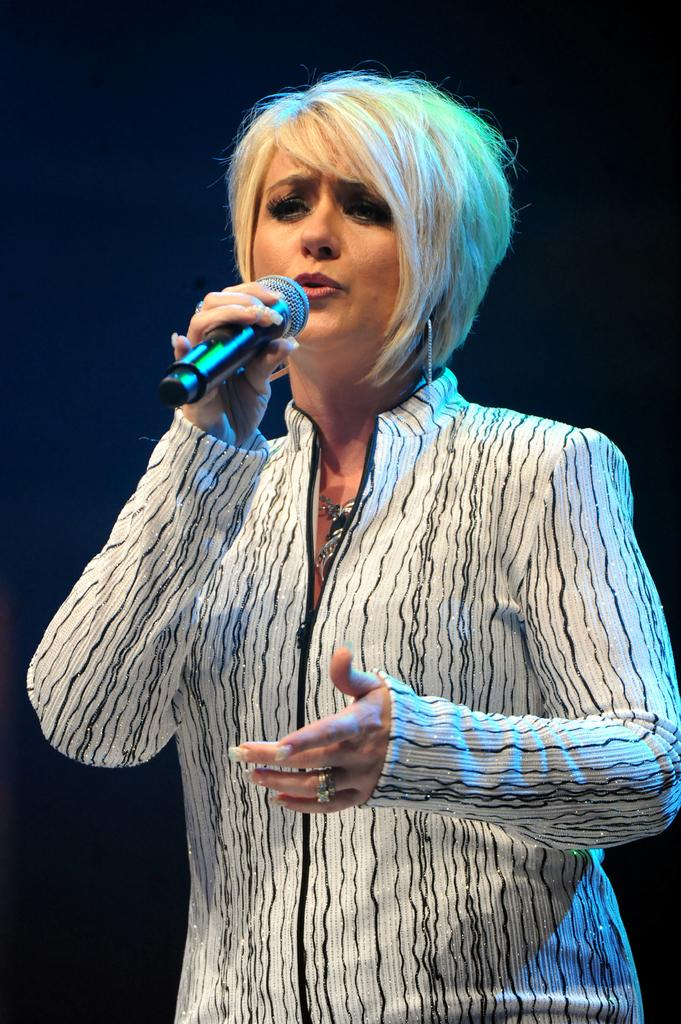Who is the main subject in the image? There is a lady in the center of the image. What is the lady doing in the image? The lady is standing and holding a mic in her hand. What type of toy is the lady playing with in the image? There is no toy present in the image; the lady is holding a mic. How many boys are visible in the image? There are no boys visible in the image; the main subject is a lady. 